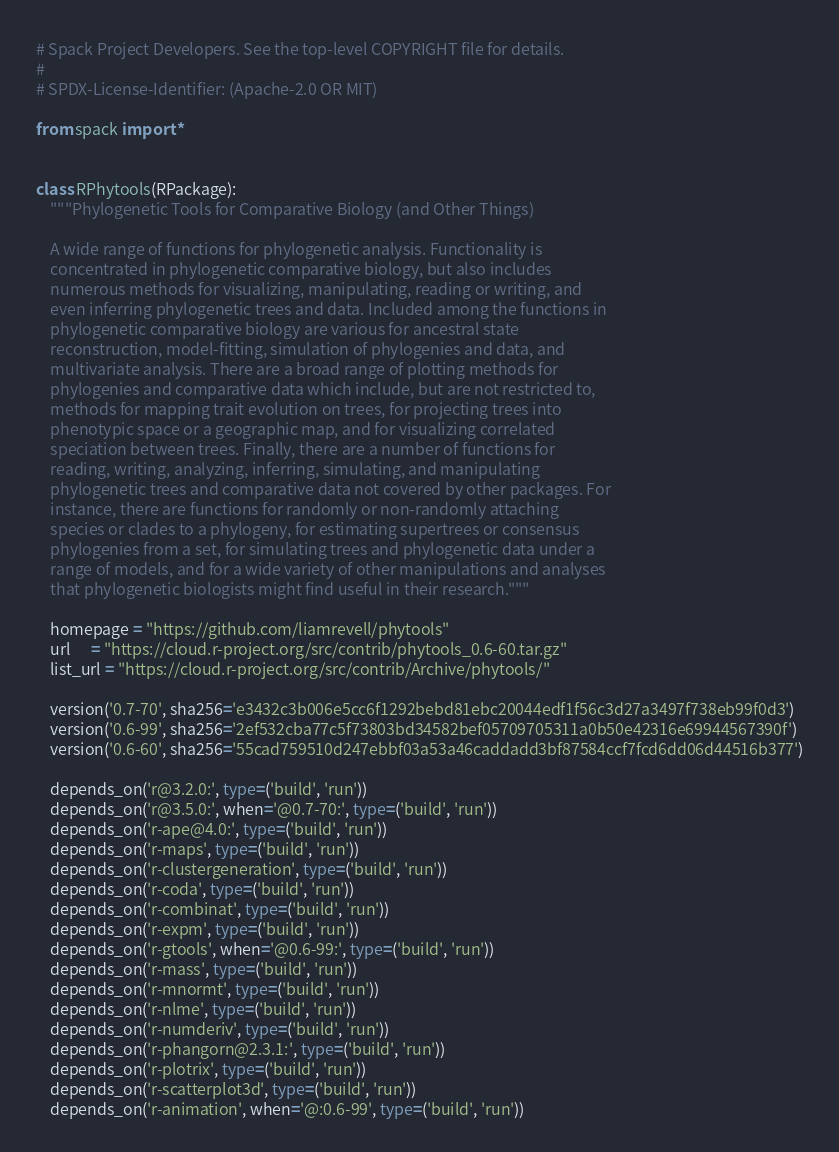<code> <loc_0><loc_0><loc_500><loc_500><_Python_># Spack Project Developers. See the top-level COPYRIGHT file for details.
#
# SPDX-License-Identifier: (Apache-2.0 OR MIT)

from spack import *


class RPhytools(RPackage):
    """Phylogenetic Tools for Comparative Biology (and Other Things)

    A wide range of functions for phylogenetic analysis. Functionality is
    concentrated in phylogenetic comparative biology, but also includes
    numerous methods for visualizing, manipulating, reading or writing, and
    even inferring phylogenetic trees and data. Included among the functions in
    phylogenetic comparative biology are various for ancestral state
    reconstruction, model-fitting, simulation of phylogenies and data, and
    multivariate analysis. There are a broad range of plotting methods for
    phylogenies and comparative data which include, but are not restricted to,
    methods for mapping trait evolution on trees, for projecting trees into
    phenotypic space or a geographic map, and for visualizing correlated
    speciation between trees. Finally, there are a number of functions for
    reading, writing, analyzing, inferring, simulating, and manipulating
    phylogenetic trees and comparative data not covered by other packages. For
    instance, there are functions for randomly or non-randomly attaching
    species or clades to a phylogeny, for estimating supertrees or consensus
    phylogenies from a set, for simulating trees and phylogenetic data under a
    range of models, and for a wide variety of other manipulations and analyses
    that phylogenetic biologists might find useful in their research."""

    homepage = "https://github.com/liamrevell/phytools"
    url      = "https://cloud.r-project.org/src/contrib/phytools_0.6-60.tar.gz"
    list_url = "https://cloud.r-project.org/src/contrib/Archive/phytools/"

    version('0.7-70', sha256='e3432c3b006e5cc6f1292bebd81ebc20044edf1f56c3d27a3497f738eb99f0d3')
    version('0.6-99', sha256='2ef532cba77c5f73803bd34582bef05709705311a0b50e42316e69944567390f')
    version('0.6-60', sha256='55cad759510d247ebbf03a53a46caddadd3bf87584ccf7fcd6dd06d44516b377')

    depends_on('r@3.2.0:', type=('build', 'run'))
    depends_on('r@3.5.0:', when='@0.7-70:', type=('build', 'run'))
    depends_on('r-ape@4.0:', type=('build', 'run'))
    depends_on('r-maps', type=('build', 'run'))
    depends_on('r-clustergeneration', type=('build', 'run'))
    depends_on('r-coda', type=('build', 'run'))
    depends_on('r-combinat', type=('build', 'run'))
    depends_on('r-expm', type=('build', 'run'))
    depends_on('r-gtools', when='@0.6-99:', type=('build', 'run'))
    depends_on('r-mass', type=('build', 'run'))
    depends_on('r-mnormt', type=('build', 'run'))
    depends_on('r-nlme', type=('build', 'run'))
    depends_on('r-numderiv', type=('build', 'run'))
    depends_on('r-phangorn@2.3.1:', type=('build', 'run'))
    depends_on('r-plotrix', type=('build', 'run'))
    depends_on('r-scatterplot3d', type=('build', 'run'))
    depends_on('r-animation', when='@:0.6-99', type=('build', 'run'))
</code> 